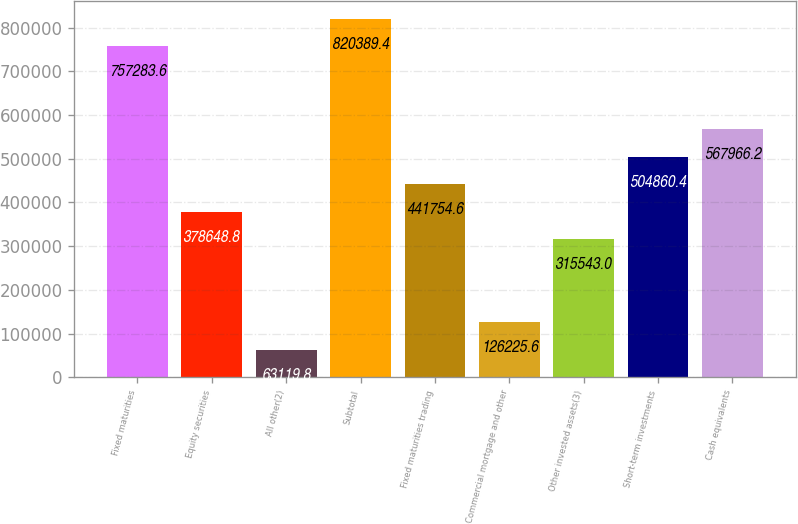Convert chart. <chart><loc_0><loc_0><loc_500><loc_500><bar_chart><fcel>Fixed maturities<fcel>Equity securities<fcel>All other(2)<fcel>Subtotal<fcel>Fixed maturities trading<fcel>Commercial mortgage and other<fcel>Other invested assets(3)<fcel>Short-term investments<fcel>Cash equivalents<nl><fcel>757284<fcel>378649<fcel>63119.8<fcel>820389<fcel>441755<fcel>126226<fcel>315543<fcel>504860<fcel>567966<nl></chart> 